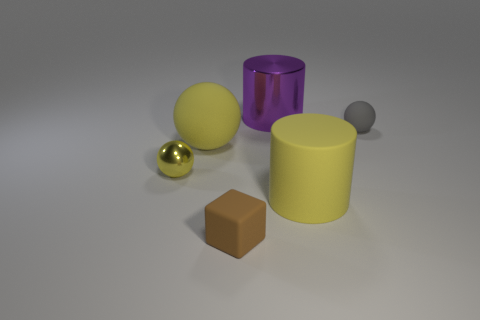Subtract all small metallic balls. How many balls are left? 2 Subtract all red cubes. How many yellow spheres are left? 2 Subtract 2 spheres. How many spheres are left? 1 Add 1 tiny gray matte spheres. How many objects exist? 7 Subtract all yellow cylinders. How many cylinders are left? 1 Subtract all cylinders. How many objects are left? 4 Subtract all cyan balls. Subtract all yellow blocks. How many balls are left? 3 Subtract all large cylinders. Subtract all tiny shiny balls. How many objects are left? 3 Add 4 brown rubber cubes. How many brown rubber cubes are left? 5 Add 2 gray rubber balls. How many gray rubber balls exist? 3 